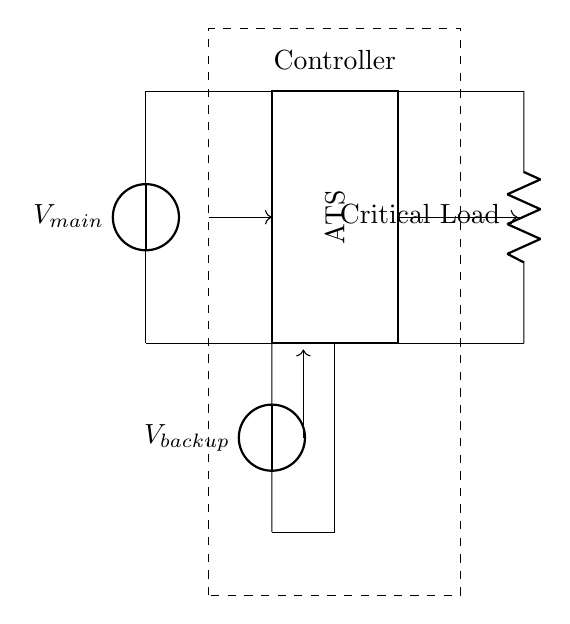What is the main power supply voltage? The circuit labels the main power supply as V_main, but does not specify a numerical value. In typical scenarios, it may be something like 120V or 240V depending on the location, but without further context, we cannot assign a specific number.
Answer: V_main What component is represented by the rectangle in the circuit? The thick rectangle indicates an Automatic Transfer Switch (ATS), which is used to switch between the main power supply and backup power supply depending on availability. It is clearly labeled in the circuit diagram.
Answer: ATS What connects the backup power supply to the ATS? The backup power supply connects to the ATS through a wire that bridges the two components vertically at the bottom and then runs horizontally to the ATS, which allows for transferring power when needed.
Answer: Wire What is the purpose of the controller in this circuit? The controller, encapsulated in a dashed rectangle, is typically responsible for monitoring the power status and controlling the operation of the ATS, triggering it to switch based on the power conditions.
Answer: Monitoring How does the ATS determine which power source to use? The ATS typically uses sensors that detect the state of the main power supply. If it fails, signals are sent to the ATS to switch to the backup power system, as seen by the connection arrows leading into and out of the controller and ATS.
Answer: Sensors What happens when the main power supply fails? When the main power supply fails, the sensors will detect this condition, prompting the ATS to switch to the backup power supply to ensure the critical load (data storage) continues functioning. This is illustrated by the flow from the backup source through the ATS to the load.
Answer: Backup power is activated How is the critical load connected in this circuit? The critical load is indicated as a resistor labeled "Critical Load" connecting from the ATS output, ensuring that essential systems such as data storage remain operational during power disruptions through a direct connection.
Answer: Directly connected 